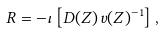Convert formula to latex. <formula><loc_0><loc_0><loc_500><loc_500>R = - \iota \left [ D ( Z ) \, { v } ( Z ) ^ { - 1 } \right ] ,</formula> 